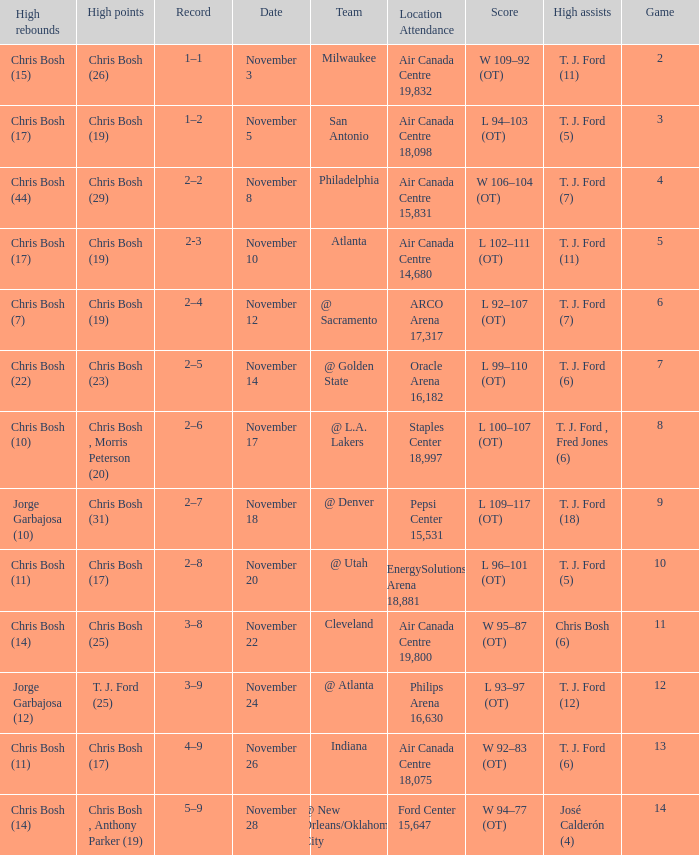Who scored the most points in game 4? Chris Bosh (29). 